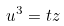<formula> <loc_0><loc_0><loc_500><loc_500>u ^ { 3 } = t z</formula> 